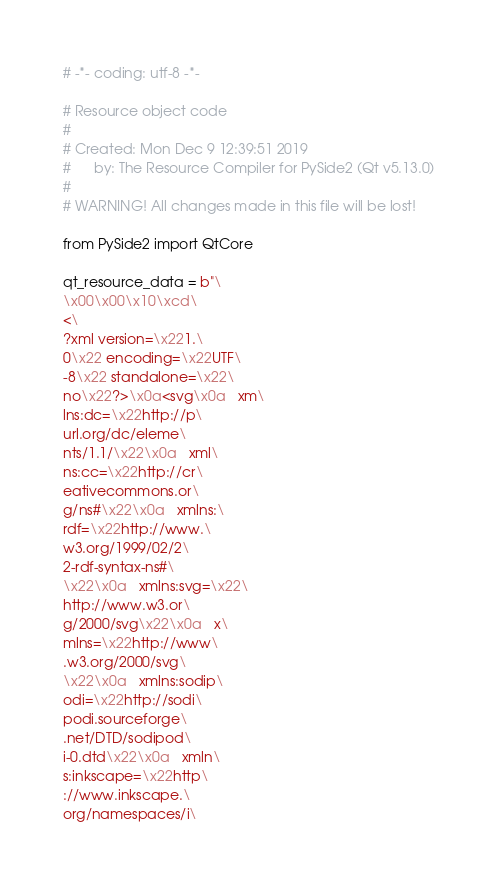<code> <loc_0><loc_0><loc_500><loc_500><_Python_># -*- coding: utf-8 -*-

# Resource object code
#
# Created: Mon Dec 9 12:39:51 2019
#      by: The Resource Compiler for PySide2 (Qt v5.13.0)
#
# WARNING! All changes made in this file will be lost!

from PySide2 import QtCore

qt_resource_data = b"\
\x00\x00\x10\xcd\
<\
?xml version=\x221.\
0\x22 encoding=\x22UTF\
-8\x22 standalone=\x22\
no\x22?>\x0a<svg\x0a   xm\
lns:dc=\x22http://p\
url.org/dc/eleme\
nts/1.1/\x22\x0a   xml\
ns:cc=\x22http://cr\
eativecommons.or\
g/ns#\x22\x0a   xmlns:\
rdf=\x22http://www.\
w3.org/1999/02/2\
2-rdf-syntax-ns#\
\x22\x0a   xmlns:svg=\x22\
http://www.w3.or\
g/2000/svg\x22\x0a   x\
mlns=\x22http://www\
.w3.org/2000/svg\
\x22\x0a   xmlns:sodip\
odi=\x22http://sodi\
podi.sourceforge\
.net/DTD/sodipod\
i-0.dtd\x22\x0a   xmln\
s:inkscape=\x22http\
://www.inkscape.\
org/namespaces/i\</code> 